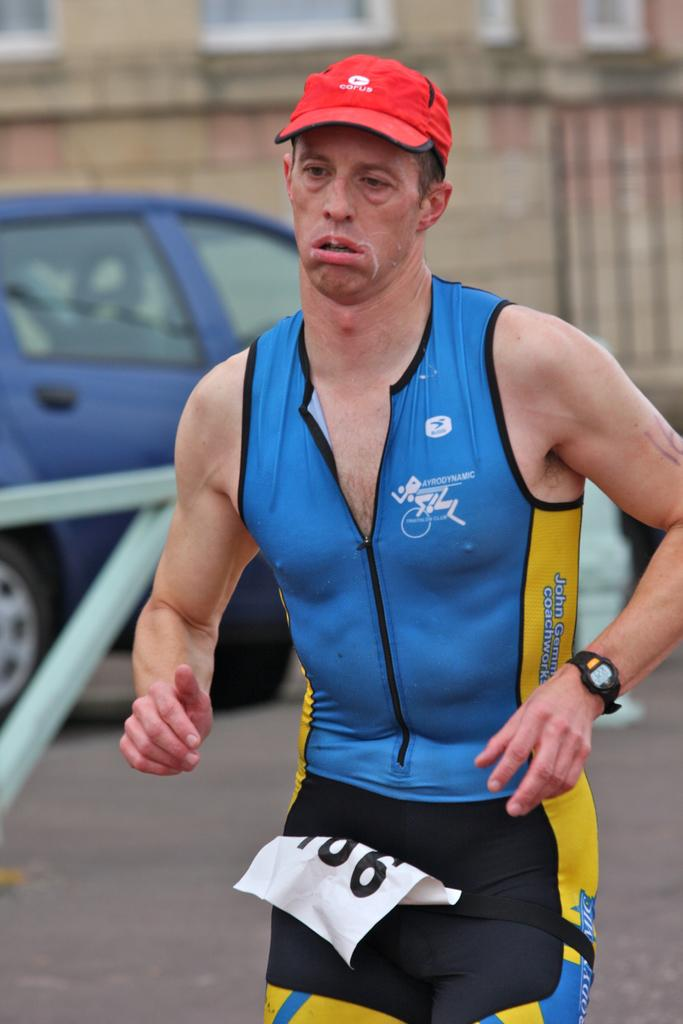<image>
Give a short and clear explanation of the subsequent image. A tired looking man wearing a hat reading COPUS. 